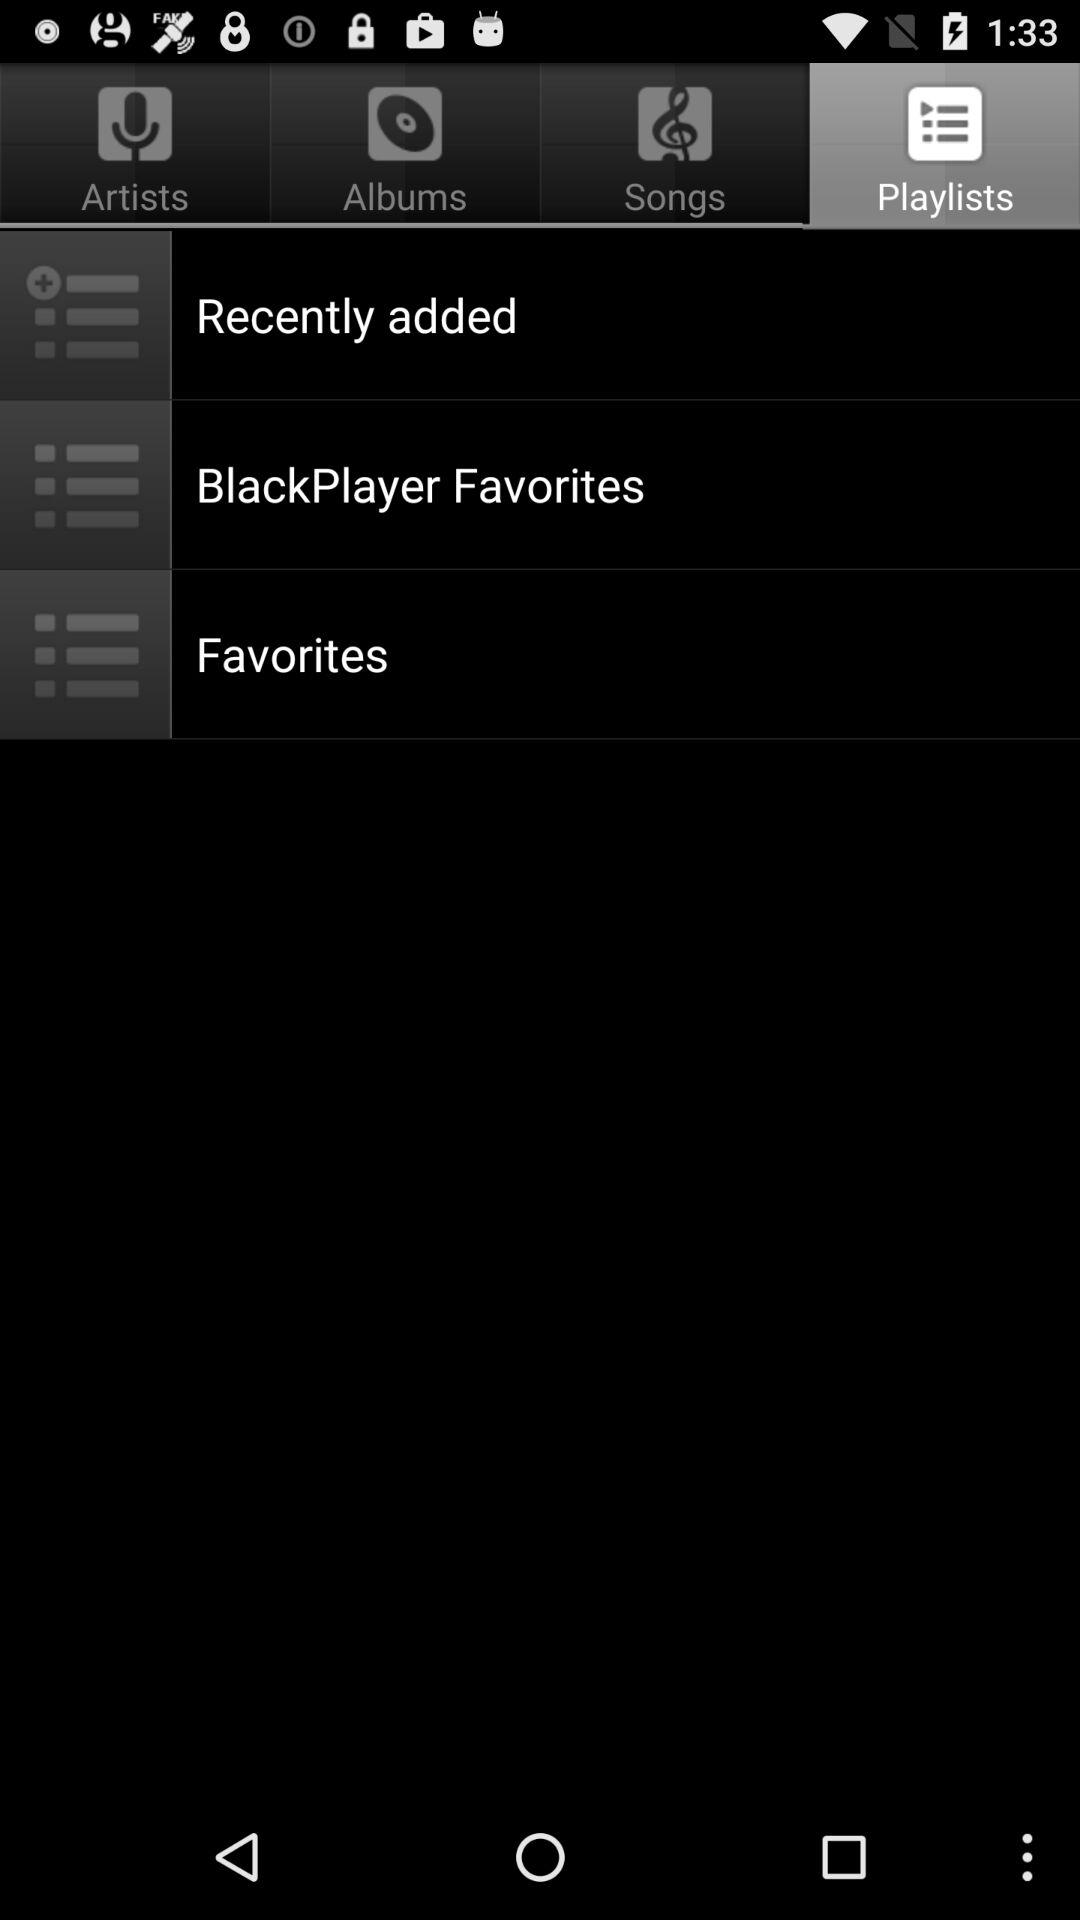Which tab is selected? The tab "Playlists" is selected. 